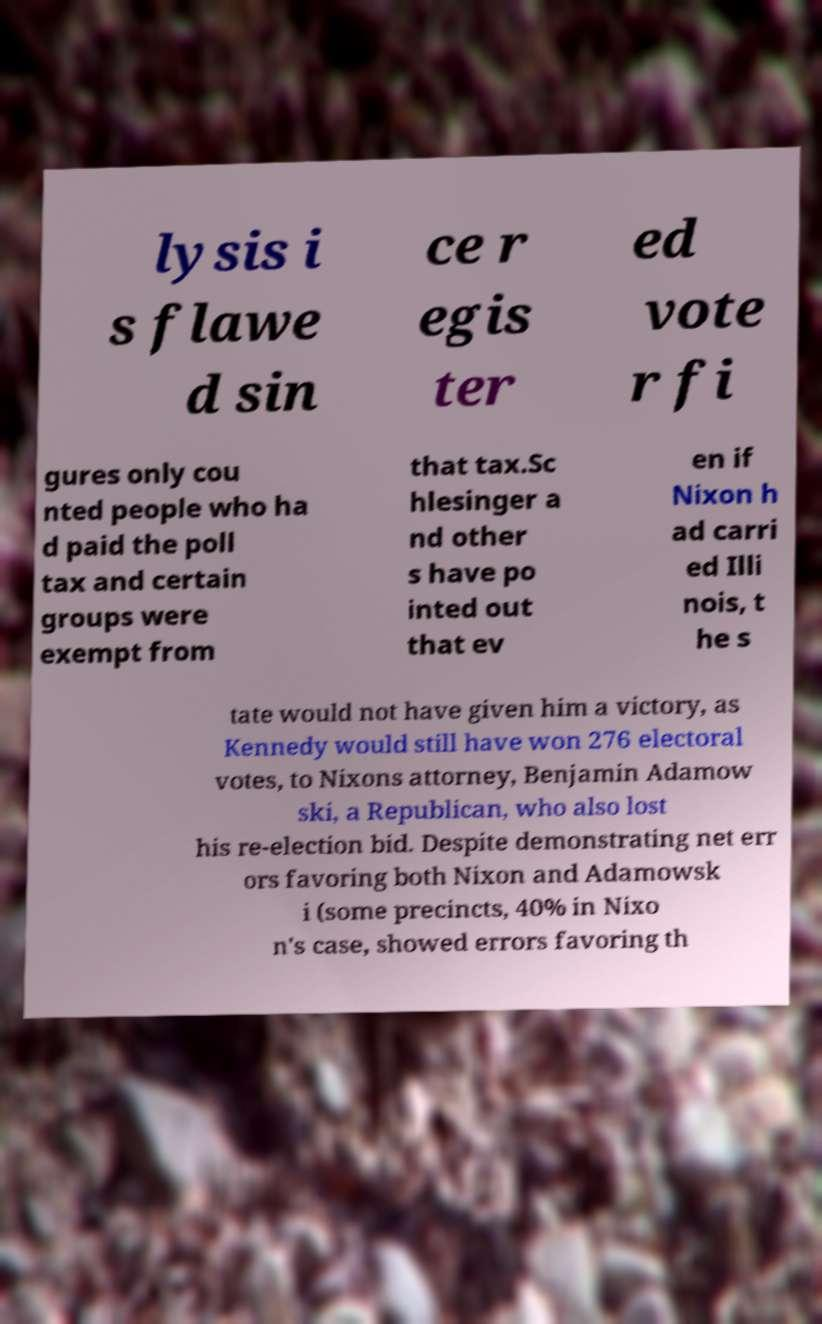What messages or text are displayed in this image? I need them in a readable, typed format. lysis i s flawe d sin ce r egis ter ed vote r fi gures only cou nted people who ha d paid the poll tax and certain groups were exempt from that tax.Sc hlesinger a nd other s have po inted out that ev en if Nixon h ad carri ed Illi nois, t he s tate would not have given him a victory, as Kennedy would still have won 276 electoral votes, to Nixons attorney, Benjamin Adamow ski, a Republican, who also lost his re-election bid. Despite demonstrating net err ors favoring both Nixon and Adamowsk i (some precincts, 40% in Nixo n's case, showed errors favoring th 